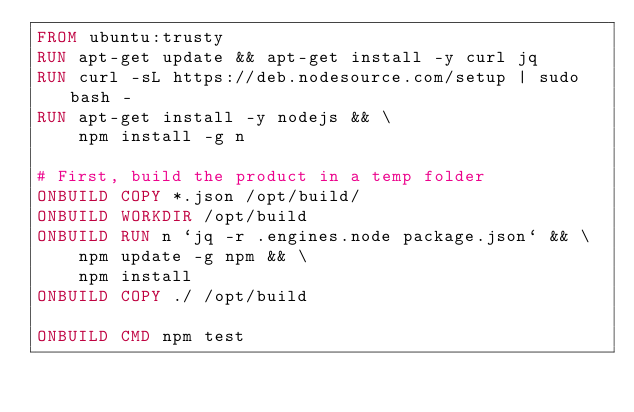<code> <loc_0><loc_0><loc_500><loc_500><_Dockerfile_>FROM ubuntu:trusty
RUN apt-get update && apt-get install -y curl jq
RUN curl -sL https://deb.nodesource.com/setup | sudo bash -
RUN apt-get install -y nodejs && \
    npm install -g n

# First, build the product in a temp folder
ONBUILD COPY *.json /opt/build/
ONBUILD WORKDIR /opt/build
ONBUILD RUN n `jq -r .engines.node package.json` && \
    npm update -g npm && \
    npm install
ONBUILD COPY ./ /opt/build

ONBUILD CMD npm test</code> 